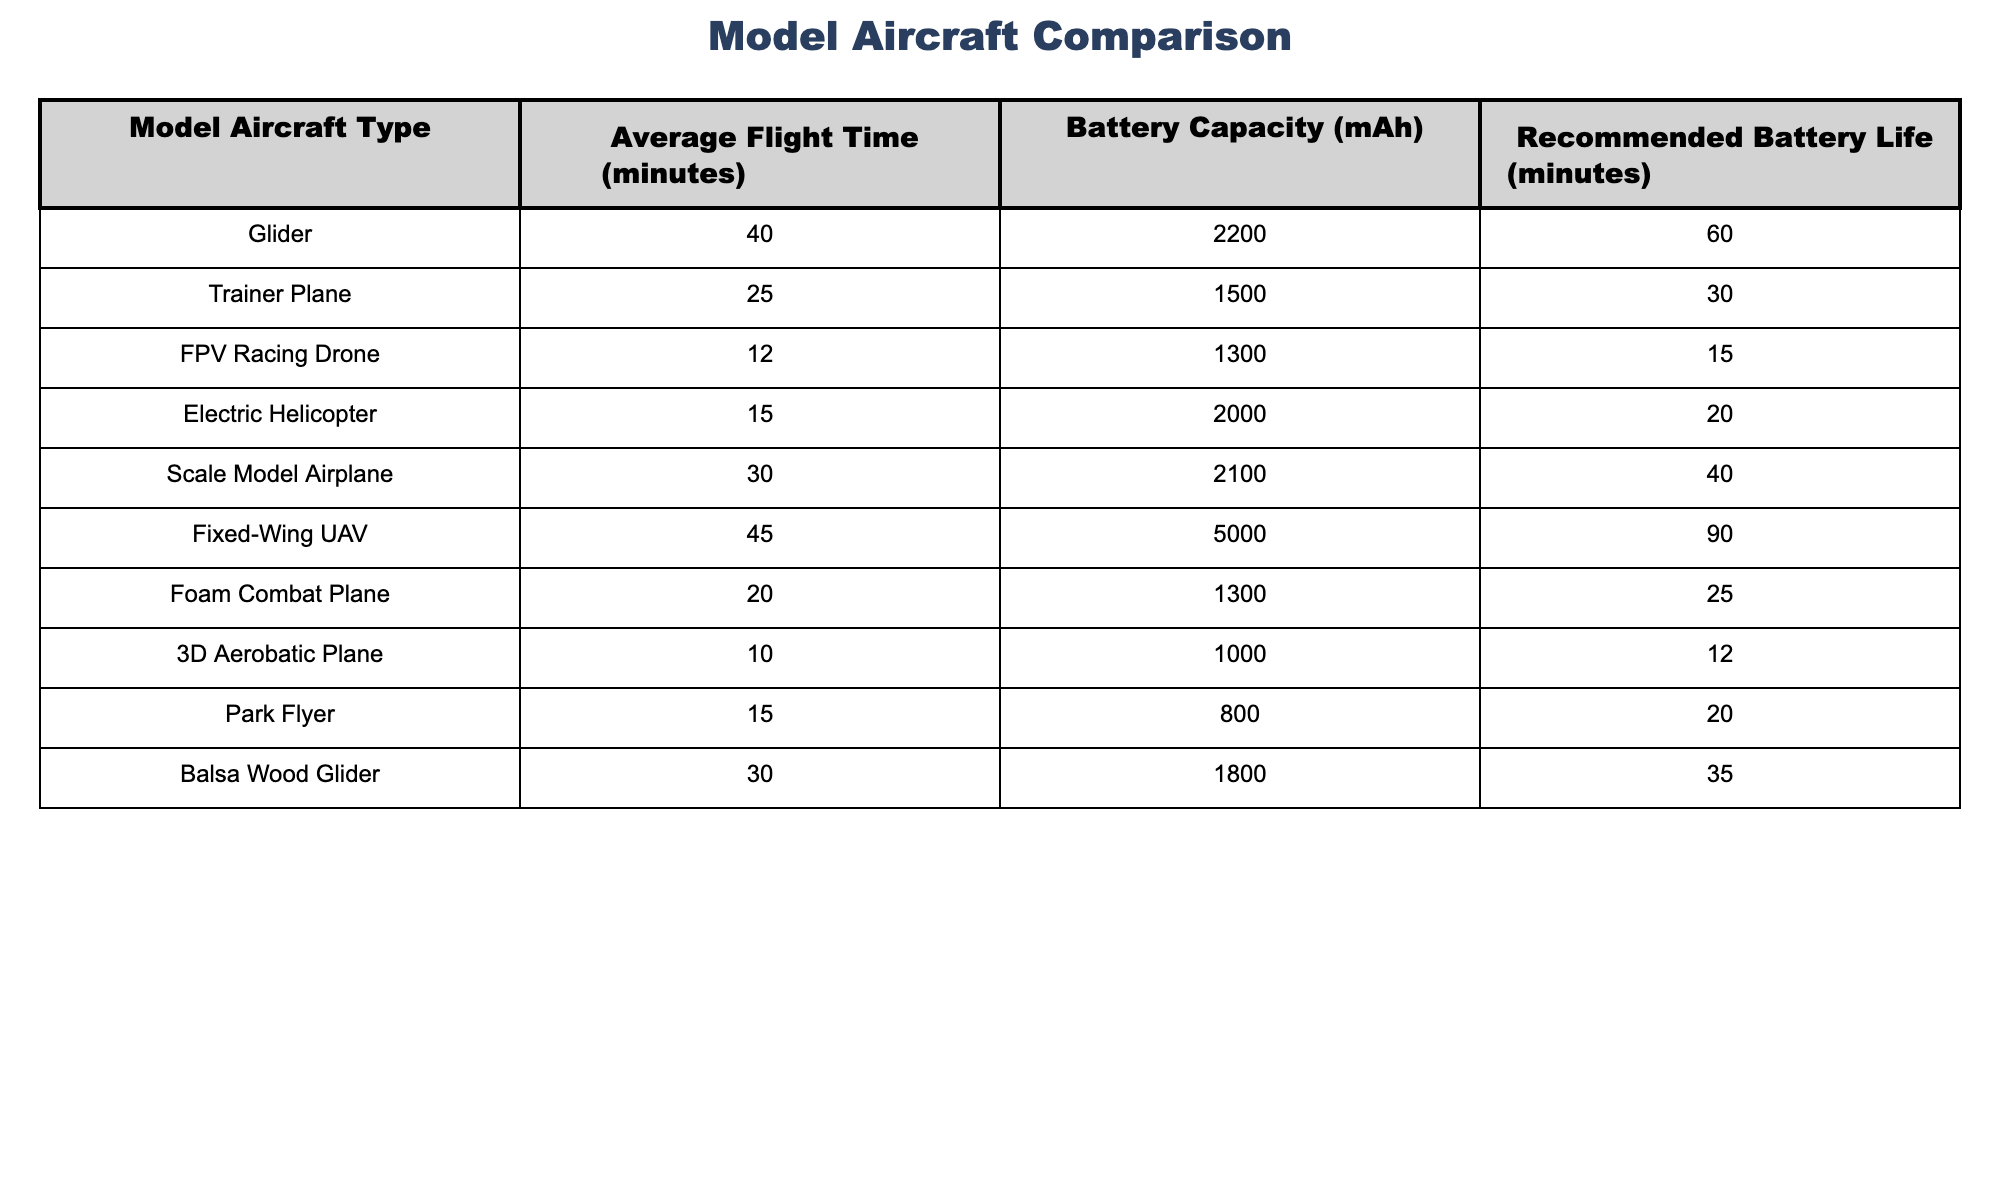What's the average flight time for gliders? The average flight time for gliders listed in the table is 40 minutes.
Answer: 40 minutes Which model aircraft has the highest battery capacity? The Fixed-Wing UAV has the highest battery capacity at 5000 mAh.
Answer: 5000 mAh Is the average flight time of a Trainer Plane greater than that of an FPV Racing Drone? The average flight time for a Trainer Plane is 25 minutes, while for an FPV Racing Drone it's 12 minutes. Since 25 minutes is greater than 12 minutes, the statement is true.
Answer: Yes What is the difference in average flight time between Scale Model Airplane and Foam Combat Plane? The average flight time for Scale Model Airplane is 30 minutes and for Foam Combat Plane it’s 20 minutes. The difference is 30 - 20 = 10 minutes.
Answer: 10 minutes Which model aircrafts have a recommended battery life of at least 30 minutes? By checking the table, the models with recommended battery life of at least 30 minutes are Glider (60), Trainer Plane (30), Fixed-Wing UAV (90), and Scale Model Airplane (40).
Answer: Glider, Trainer Plane, Fixed-Wing UAV, Scale Model Airplane What is the total battery capacity of all the model aircraft combined? Adding the battery capacities: 2200 + 1500 + 1300 + 2000 + 2100 + 5000 + 1300 + 1000 + 800 + 1800 = 20,000 mAh.
Answer: 20,000 mAh How many aircraft types have an average flight time of less than 20 minutes? The aircraft types with flight times less than 20 minutes are FPV Racing Drone (12) and 3D Aerobatic Plane (10) and Electric Helicopter (15), totaling 3 types.
Answer: 3 types Which aircraft type has the shortest recommended battery life? The FPV Racing Drone has the shortest recommended battery life of 15 minutes as stated in the table.
Answer: 15 minutes What is the average battery capacity of the three aircraft types with the shortest flight times? The aircraft with the shortest flight times are FPV Racing Drone (1300 mAh), 3D Aerobatic Plane (1000 mAh), and Electric Helicopter (2000 mAh). The sum is 1300 + 1000 + 2000 = 4300 mAh, and there are 3 types. The average is 4300 / 3 = approximately 1433.33 mAh.
Answer: 1433.33 mAh Does the average flight time of the Fixed-Wing UAV exceed that of any other model? The Fixed-Wing UAV has an average flight time of 45 minutes, which is greater than all others since the maximum flight time noted is 40 minutes for the Glider. Thus, it exceeds all others.
Answer: Yes If you combine the flight times of Scale Model Airplane, Electric Helicopter, and Park Flyer, what total do you get? The flight times to combine are: Scale Model Airplane (30), Electric Helicopter (15), and Park Flyer (15). Adding these gives 30 + 15 + 15 = 60 minutes.
Answer: 60 minutes 